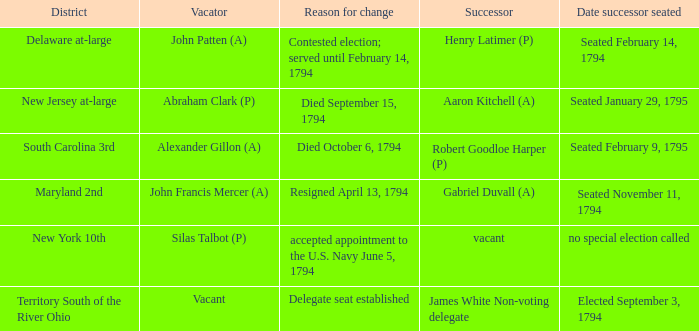Name the date successor seated is south carolina 3rd Seated February 9, 1795. Help me parse the entirety of this table. {'header': ['District', 'Vacator', 'Reason for change', 'Successor', 'Date successor seated'], 'rows': [['Delaware at-large', 'John Patten (A)', 'Contested election; served until February 14, 1794', 'Henry Latimer (P)', 'Seated February 14, 1794'], ['New Jersey at-large', 'Abraham Clark (P)', 'Died September 15, 1794', 'Aaron Kitchell (A)', 'Seated January 29, 1795'], ['South Carolina 3rd', 'Alexander Gillon (A)', 'Died October 6, 1794', 'Robert Goodloe Harper (P)', 'Seated February 9, 1795'], ['Maryland 2nd', 'John Francis Mercer (A)', 'Resigned April 13, 1794', 'Gabriel Duvall (A)', 'Seated November 11, 1794'], ['New York 10th', 'Silas Talbot (P)', 'accepted appointment to the U.S. Navy June 5, 1794', 'vacant', 'no special election called'], ['Territory South of the River Ohio', 'Vacant', 'Delegate seat established', 'James White Non-voting delegate', 'Elected September 3, 1794']]} 